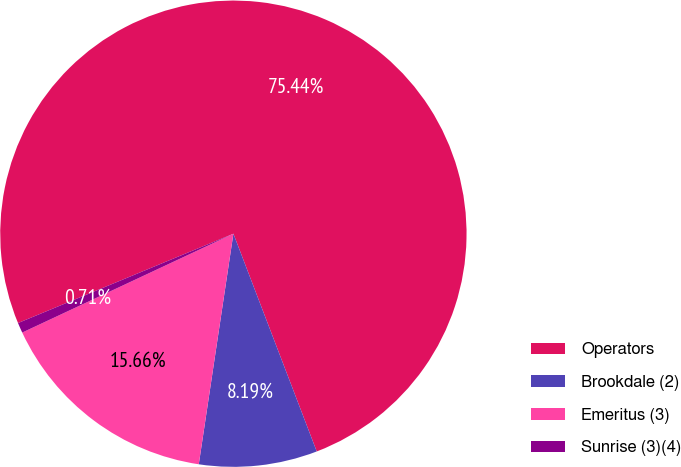Convert chart. <chart><loc_0><loc_0><loc_500><loc_500><pie_chart><fcel>Operators<fcel>Brookdale (2)<fcel>Emeritus (3)<fcel>Sunrise (3)(4)<nl><fcel>75.44%<fcel>8.19%<fcel>15.66%<fcel>0.71%<nl></chart> 